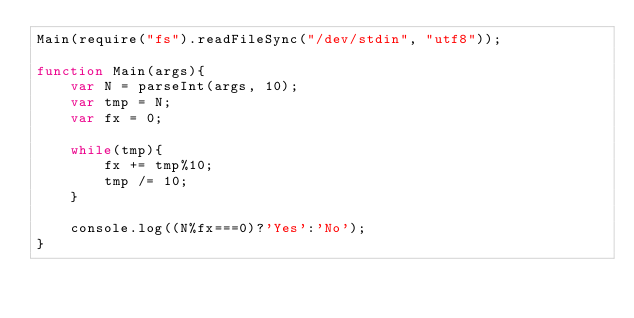<code> <loc_0><loc_0><loc_500><loc_500><_JavaScript_>Main(require("fs").readFileSync("/dev/stdin", "utf8"));

function Main(args){
    var N = parseInt(args, 10);
    var tmp = N;
    var fx = 0;

    while(tmp){
        fx += tmp%10;
        tmp /= 10;
    }

    console.log((N%fx===0)?'Yes':'No');
}</code> 